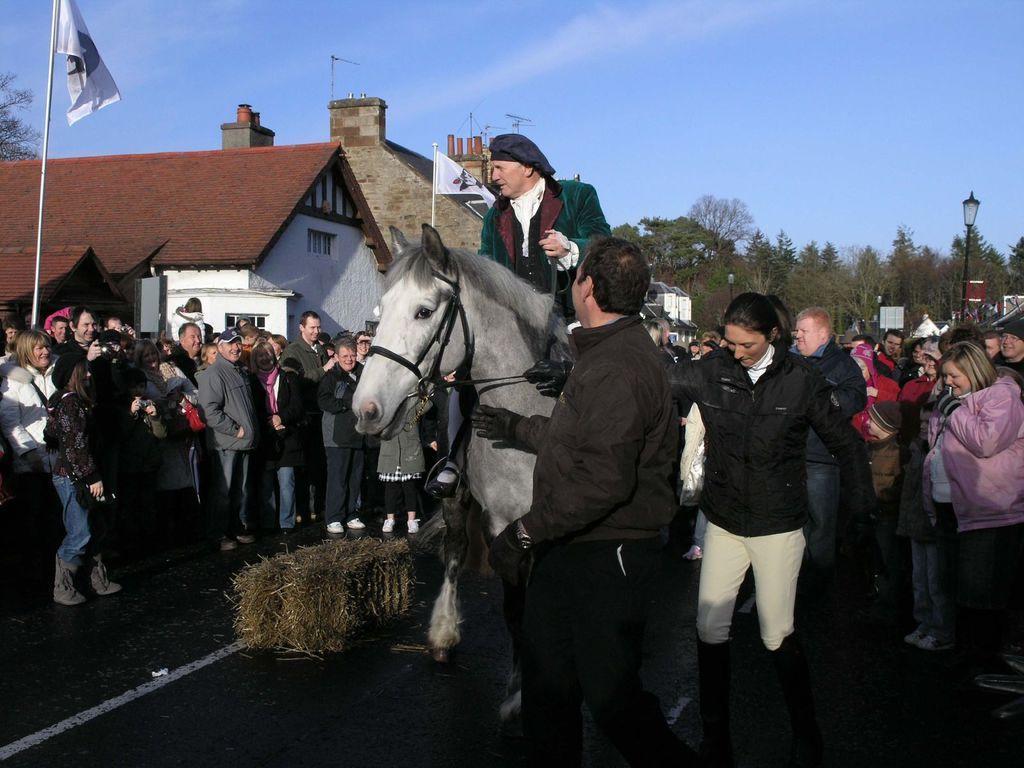In one or two sentences, can you explain what this image depicts? In the image there are group of people. In middle there is a man sitting on horse and riding it, on right side there are trees with green leaves and street light. On left side there are some buildings and a flag and there is a sky on top at bottom there is a road which is in black road. 